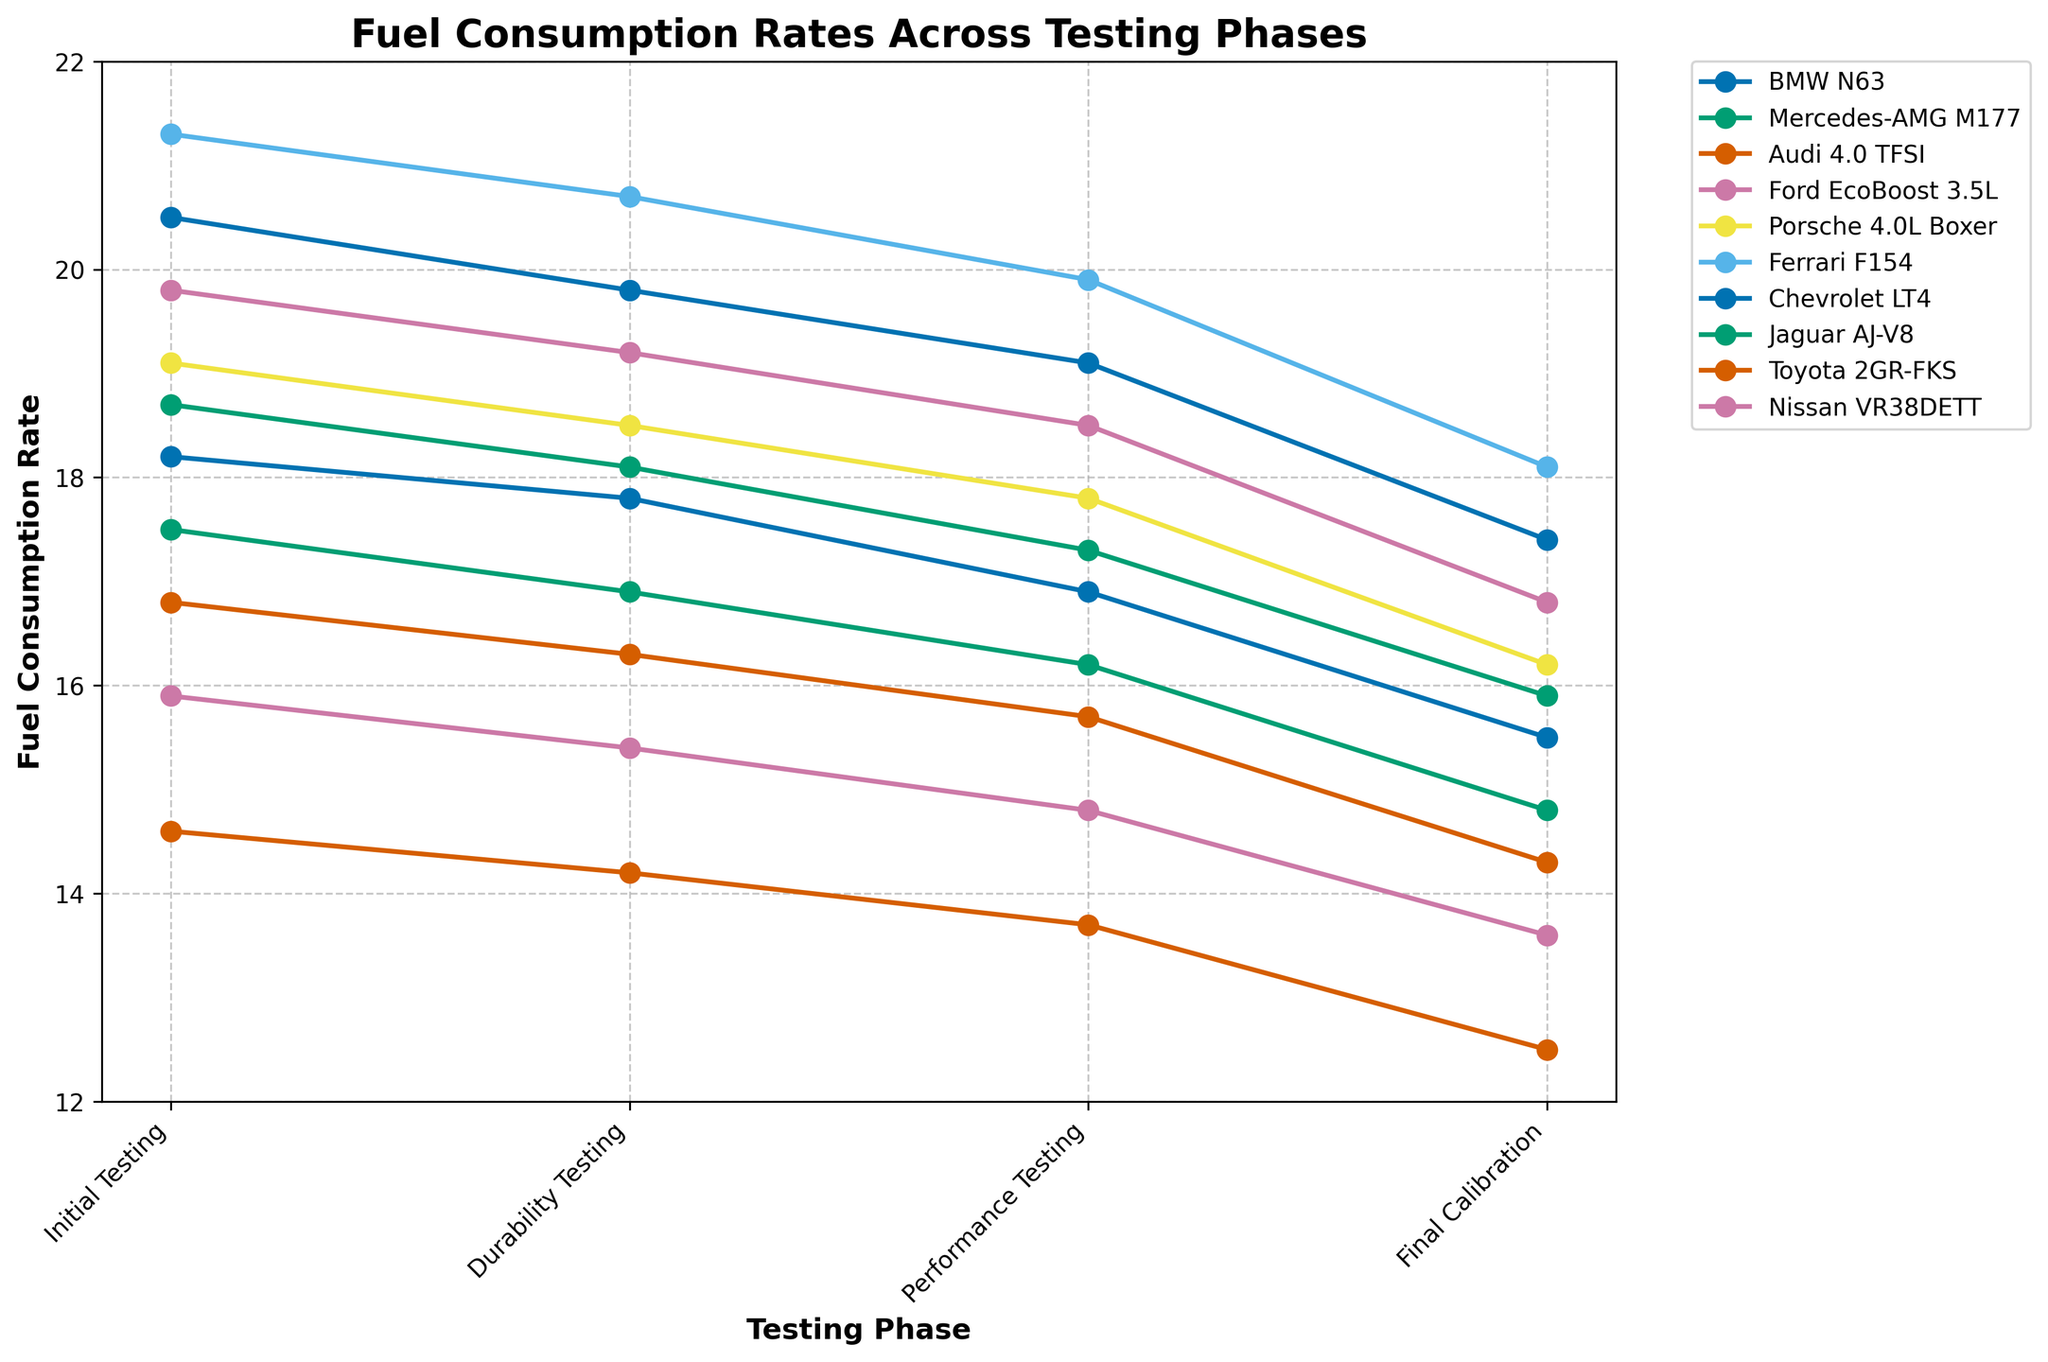What is the trend observed in the fuel consumption rates across all engine models during the testing phases? All engine models show a decreasing trend in fuel consumption rates from the Initial Testing phase to the Final Calibration phase. Specifically, the rates decline steadily as the testing progresses through Durability, Performance, and finally reach the lowest in the Final Calibration phase.
Answer: Decreasing Which engine model has the lowest fuel consumption rate during the Final Calibration phase? By looking at the Final Calibration phase data points, the lowest fuel consumption rate is for the Toyota 2GR-FKS, which is at 12.5.
Answer: Toyota 2GR-FKS Which engine model shows the greatest decline in fuel consumption rate from Initial Testing to Final Calibration? For each engine model, subtract the Final Calibration rate from the Initial Testing rate: 
BMW N63: 18.2 - 15.5 = 2.7 
Mercedes-AMG M177: 17.5 - 14.8 = 2.7
Audi 4.0 TFSI: 16.8 - 14.3 = 2.5
Ford EcoBoost 3.5L: 15.9 - 13.6 = 2.3
Porsche 4.0L Boxer: 19.1 - 16.2 = 2.9
Ferrari F154: 21.3 - 18.1 = 3.2
Chevrolet LT4: 20.5 - 17.4 = 3.1
Jaguar AJ-V8: 18.7 - 15.9 = 2.8
Toyota 2GR-FKS: 14.6 - 12.5 = 2.1
Nissan VR38DETT: 19.8 - 16.8 = 3.0
The Ferrari F154 shows the greatest decline with a 3.2 difference.
Answer: Ferrari F154 Between BMW N63 and Porsche 4.0L Boxer, which engine model has higher fuel consumption rate during Durability Testing? Compare the data points for Durability Testing:
BMW N63: 17.8
Porsche 4.0L Boxer: 18.5
The Porsche 4.0L Boxer has a higher rate.
Answer: Porsche 4.0L Boxer What is the average fuel consumption rate during the Performance Testing phase across all engine models? Add up all Performance Testing rates and divide by the number of models:
(16.9 + 16.2 + 15.7 + 14.8 + 17.8 + 19.9 + 19.1 + 17.3 + 13.7 + 18.5) / 10 = 17.19
Answer: 17.19 How much lower is the fuel consumption rate for the Toyota 2GR-FKS compared to the Mercedes-AMG M177 during Initial Testing? Subtract the Initial Testing rate of the Toyota 2GR-FKS from the Mercedes-AMG M177:
17.5 - 14.6 = 2.9
Answer: 2.9 